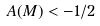<formula> <loc_0><loc_0><loc_500><loc_500>A ( M ) < - 1 / 2</formula> 